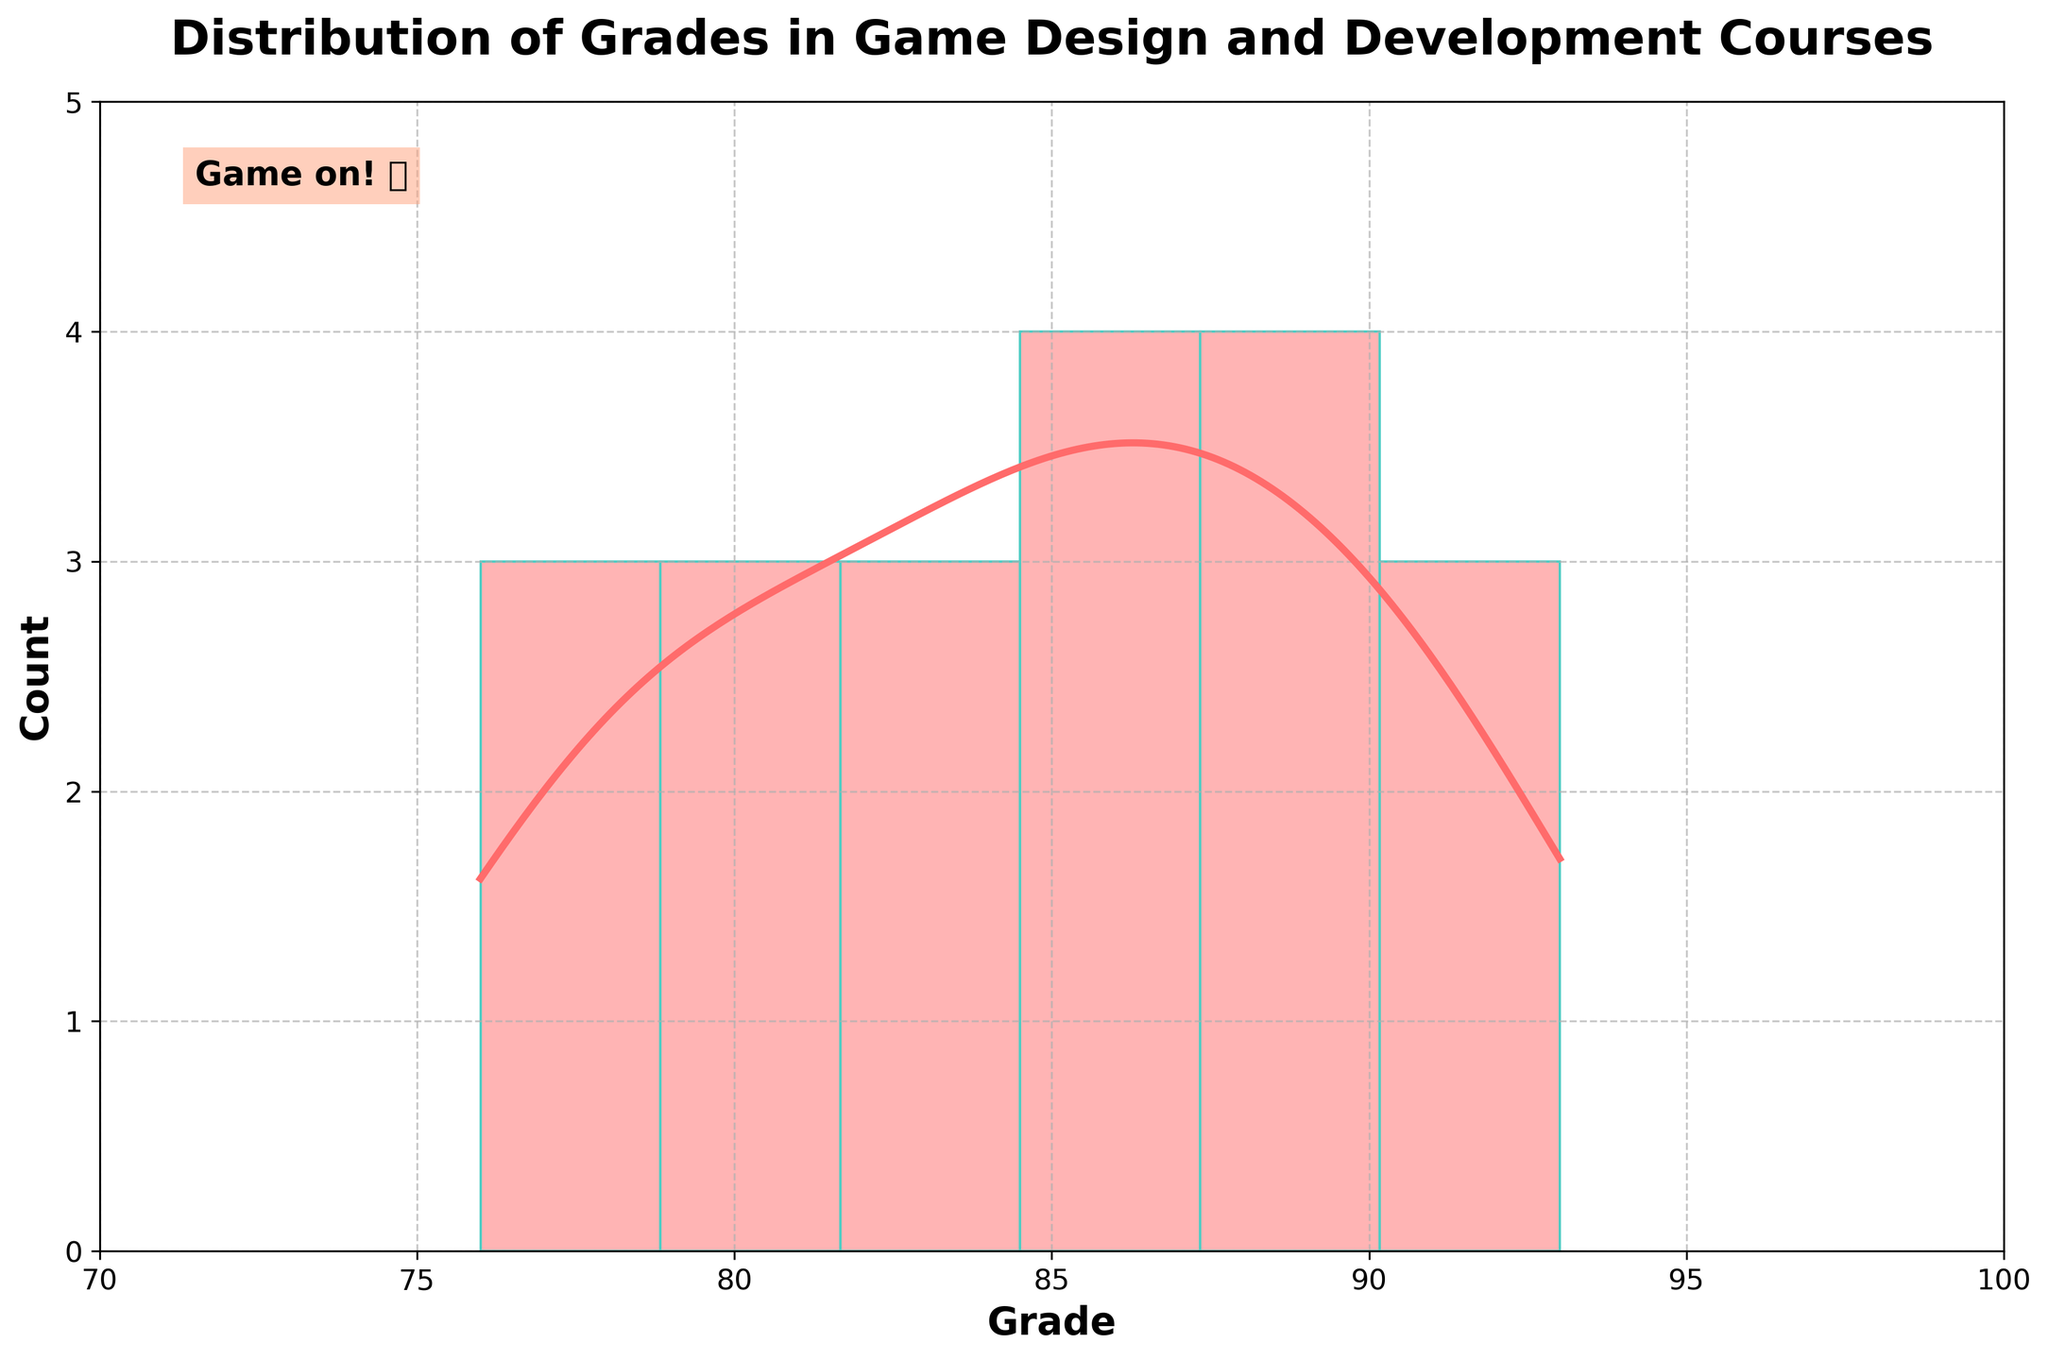What is the title of the plot? The title is displayed at the top of the plot, it reads "Distribution of Grades in Game Design and Development Courses".
Answer: Distribution of Grades in Game Design and Development Courses What are the x and y labels in the plot? The x and y labels are shown on the horizontal and vertical axes, respectively. The x label is "Grade" and the y label is "Count".
Answer: Grade; Count What is the range of grades shown on the x-axis? The x-axis limits are set from 70 to 100, as indicated by the x-axis spans marked from 70 to 100 clearly.
Answer: 70 to 100 How many grades are in the 80-85 range? Look at the histogram bars that fall within the 80-85 range on the x-axis. Count the bars and their heights to determine the number of grades in that range. The bar suggests a height representing 5 grades.
Answer: 5 grades Which grade range has the highest frequency? The tallest histogram bar corresponds to the grade range with the highest frequency. By observing the plot, the height of the bar in the 85-90 range is the highest.
Answer: 85-90 range What is the approximate count for the grade of 78? Locate the bar corresponding to the grade of 78 on the x-axis. The height of this bar indicates the count, which appears to be around 1.
Answer: 1 What is the grade with the highest density in the KDE curve? The highest point on the KDE curve represents the grade with the highest density. This peak appears near the 88-90 range on the x-axis.
Answer: 89 What's the median grade in the histogram? Determine the middle value of the grades by observing the spread of the histogram. The median grade falls around the center of the x-axis range, approximately around 85-88.
Answer: Around 86.5 Which is more common, grades higher than 85 or grades lower than 85? Compare the area under the histogram and KDE curve for grades above 85 versus grades below 85. There are more bars and KDE density for grades higher than 85.
Answer: More common higher than 85 How does the color scheme affect the readability of this plot? The color scheme features several distinct colors making it visually appealing and helps differentiate the histogram bars, KDE curve, and gridlines, enhancing readability and comprehension.
Answer: It improves readability and distinction 